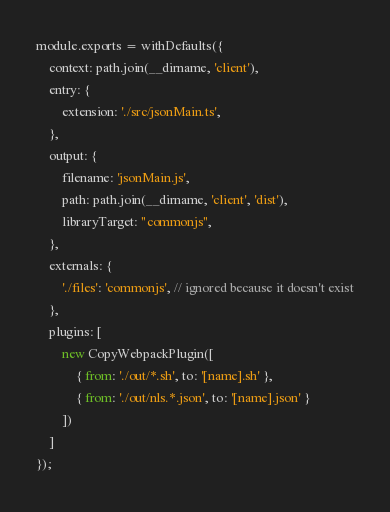<code> <loc_0><loc_0><loc_500><loc_500><_JavaScript_>module.exports = withDefaults({
	context: path.join(__dirname, 'client'),
	entry: {
		extension: './src/jsonMain.ts',
	},
	output: {
		filename: 'jsonMain.js',
		path: path.join(__dirname, 'client', 'dist'),
		libraryTarget: "commonjs",
	},
	externals: {
		'./files': 'commonjs', // ignored because it doesn't exist
	},
	plugins: [
		new CopyWebpackPlugin([
			{ from: './out/*.sh', to: '[name].sh' },
			{ from: './out/nls.*.json', to: '[name].json' }
		])
	]
});
</code> 